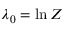<formula> <loc_0><loc_0><loc_500><loc_500>\lambda _ { 0 } = \ln Z</formula> 